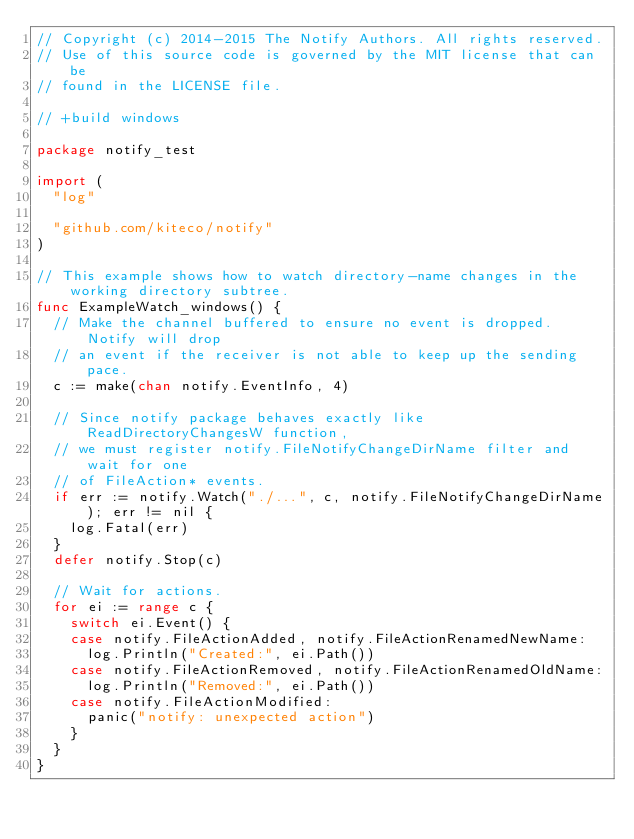<code> <loc_0><loc_0><loc_500><loc_500><_Go_>// Copyright (c) 2014-2015 The Notify Authors. All rights reserved.
// Use of this source code is governed by the MIT license that can be
// found in the LICENSE file.

// +build windows

package notify_test

import (
	"log"

	"github.com/kiteco/notify"
)

// This example shows how to watch directory-name changes in the working directory subtree.
func ExampleWatch_windows() {
	// Make the channel buffered to ensure no event is dropped. Notify will drop
	// an event if the receiver is not able to keep up the sending pace.
	c := make(chan notify.EventInfo, 4)

	// Since notify package behaves exactly like ReadDirectoryChangesW function,
	// we must register notify.FileNotifyChangeDirName filter and wait for one
	// of FileAction* events.
	if err := notify.Watch("./...", c, notify.FileNotifyChangeDirName); err != nil {
		log.Fatal(err)
	}
	defer notify.Stop(c)

	// Wait for actions.
	for ei := range c {
		switch ei.Event() {
		case notify.FileActionAdded, notify.FileActionRenamedNewName:
			log.Println("Created:", ei.Path())
		case notify.FileActionRemoved, notify.FileActionRenamedOldName:
			log.Println("Removed:", ei.Path())
		case notify.FileActionModified:
			panic("notify: unexpected action")
		}
	}
}
</code> 